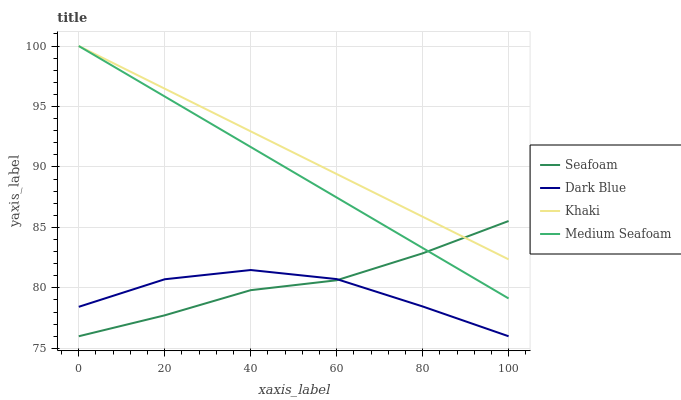Does Seafoam have the minimum area under the curve?
Answer yes or no. No. Does Seafoam have the maximum area under the curve?
Answer yes or no. No. Is Seafoam the smoothest?
Answer yes or no. No. Is Seafoam the roughest?
Answer yes or no. No. Does Khaki have the lowest value?
Answer yes or no. No. Does Seafoam have the highest value?
Answer yes or no. No. Is Dark Blue less than Khaki?
Answer yes or no. Yes. Is Khaki greater than Dark Blue?
Answer yes or no. Yes. Does Dark Blue intersect Khaki?
Answer yes or no. No. 